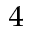Convert formula to latex. <formula><loc_0><loc_0><loc_500><loc_500>_ { 4 }</formula> 